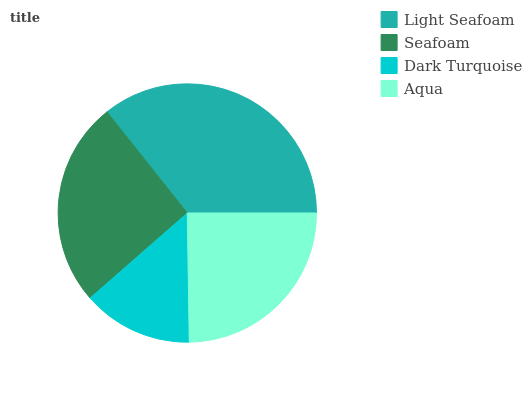Is Dark Turquoise the minimum?
Answer yes or no. Yes. Is Light Seafoam the maximum?
Answer yes or no. Yes. Is Seafoam the minimum?
Answer yes or no. No. Is Seafoam the maximum?
Answer yes or no. No. Is Light Seafoam greater than Seafoam?
Answer yes or no. Yes. Is Seafoam less than Light Seafoam?
Answer yes or no. Yes. Is Seafoam greater than Light Seafoam?
Answer yes or no. No. Is Light Seafoam less than Seafoam?
Answer yes or no. No. Is Seafoam the high median?
Answer yes or no. Yes. Is Aqua the low median?
Answer yes or no. Yes. Is Light Seafoam the high median?
Answer yes or no. No. Is Light Seafoam the low median?
Answer yes or no. No. 